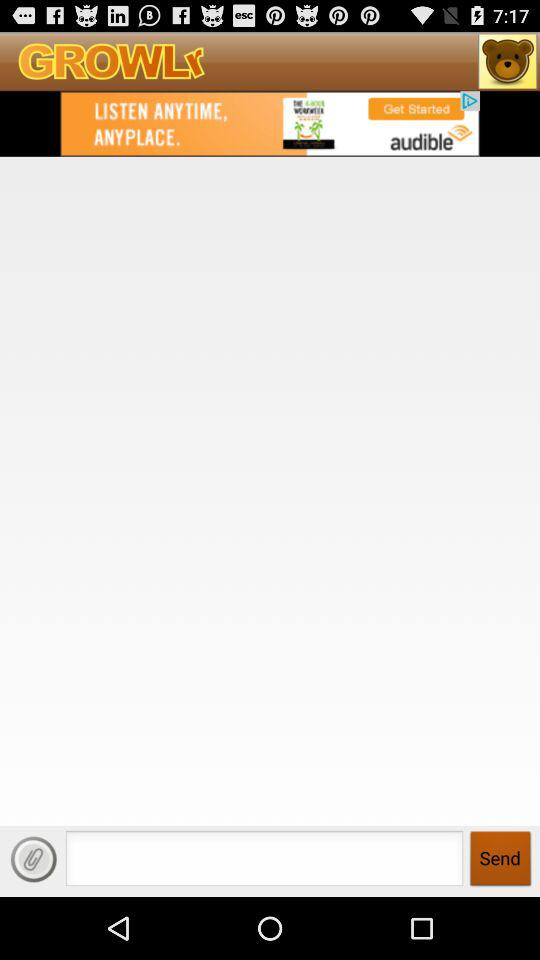What is the application name? The application name is "GROWLr". 